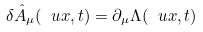<formula> <loc_0><loc_0><loc_500><loc_500>\delta \hat { A } _ { \mu } ( \ u x , t ) = \partial _ { \mu } \Lambda ( \ u x , t )</formula> 